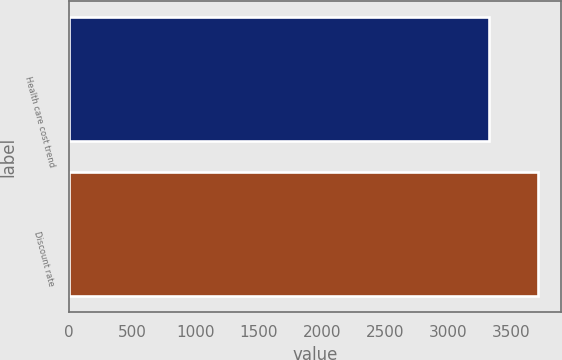<chart> <loc_0><loc_0><loc_500><loc_500><bar_chart><fcel>Health care cost trend<fcel>Discount rate<nl><fcel>3321<fcel>3708<nl></chart> 